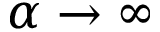Convert formula to latex. <formula><loc_0><loc_0><loc_500><loc_500>\alpha \to \infty</formula> 